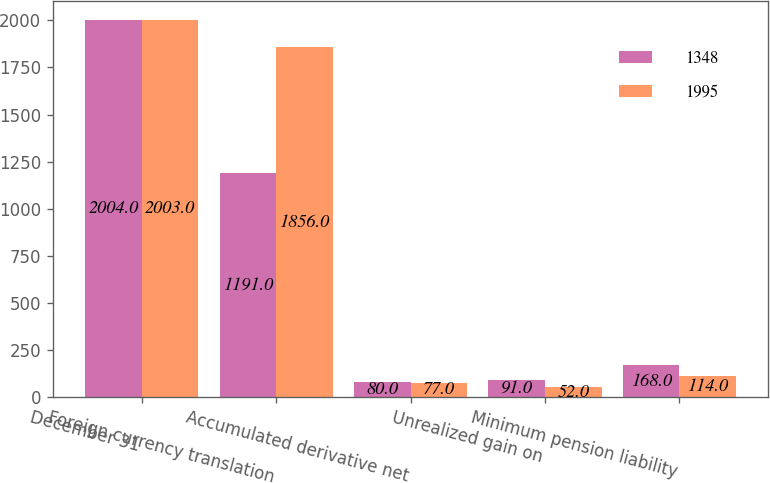Convert chart to OTSL. <chart><loc_0><loc_0><loc_500><loc_500><stacked_bar_chart><ecel><fcel>December 31<fcel>Foreign currency translation<fcel>Accumulated derivative net<fcel>Unrealized gain on<fcel>Minimum pension liability<nl><fcel>1348<fcel>2004<fcel>1191<fcel>80<fcel>91<fcel>168<nl><fcel>1995<fcel>2003<fcel>1856<fcel>77<fcel>52<fcel>114<nl></chart> 